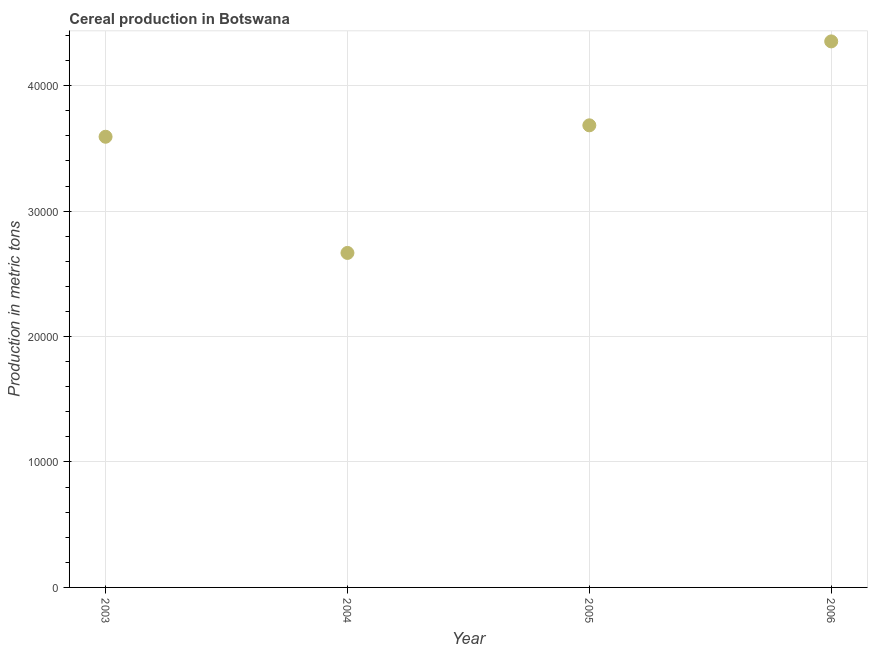What is the cereal production in 2004?
Give a very brief answer. 2.67e+04. Across all years, what is the maximum cereal production?
Give a very brief answer. 4.35e+04. Across all years, what is the minimum cereal production?
Ensure brevity in your answer.  2.67e+04. In which year was the cereal production minimum?
Ensure brevity in your answer.  2004. What is the sum of the cereal production?
Make the answer very short. 1.43e+05. What is the difference between the cereal production in 2005 and 2006?
Your answer should be very brief. -6691. What is the average cereal production per year?
Make the answer very short. 3.57e+04. What is the median cereal production?
Make the answer very short. 3.64e+04. What is the ratio of the cereal production in 2003 to that in 2006?
Your answer should be very brief. 0.83. Is the difference between the cereal production in 2004 and 2006 greater than the difference between any two years?
Make the answer very short. Yes. What is the difference between the highest and the second highest cereal production?
Give a very brief answer. 6691. Is the sum of the cereal production in 2004 and 2005 greater than the maximum cereal production across all years?
Your answer should be compact. Yes. What is the difference between the highest and the lowest cereal production?
Ensure brevity in your answer.  1.69e+04. Does the cereal production monotonically increase over the years?
Offer a very short reply. No. How many dotlines are there?
Keep it short and to the point. 1. What is the difference between two consecutive major ticks on the Y-axis?
Give a very brief answer. 10000. Does the graph contain any zero values?
Provide a succinct answer. No. Does the graph contain grids?
Keep it short and to the point. Yes. What is the title of the graph?
Make the answer very short. Cereal production in Botswana. What is the label or title of the Y-axis?
Ensure brevity in your answer.  Production in metric tons. What is the Production in metric tons in 2003?
Make the answer very short. 3.59e+04. What is the Production in metric tons in 2004?
Your response must be concise. 2.67e+04. What is the Production in metric tons in 2005?
Offer a terse response. 3.68e+04. What is the Production in metric tons in 2006?
Provide a short and direct response. 4.35e+04. What is the difference between the Production in metric tons in 2003 and 2004?
Give a very brief answer. 9262. What is the difference between the Production in metric tons in 2003 and 2005?
Ensure brevity in your answer.  -911. What is the difference between the Production in metric tons in 2003 and 2006?
Ensure brevity in your answer.  -7602. What is the difference between the Production in metric tons in 2004 and 2005?
Offer a terse response. -1.02e+04. What is the difference between the Production in metric tons in 2004 and 2006?
Ensure brevity in your answer.  -1.69e+04. What is the difference between the Production in metric tons in 2005 and 2006?
Provide a short and direct response. -6691. What is the ratio of the Production in metric tons in 2003 to that in 2004?
Provide a succinct answer. 1.35. What is the ratio of the Production in metric tons in 2003 to that in 2006?
Offer a very short reply. 0.82. What is the ratio of the Production in metric tons in 2004 to that in 2005?
Your answer should be compact. 0.72. What is the ratio of the Production in metric tons in 2004 to that in 2006?
Make the answer very short. 0.61. What is the ratio of the Production in metric tons in 2005 to that in 2006?
Your response must be concise. 0.85. 